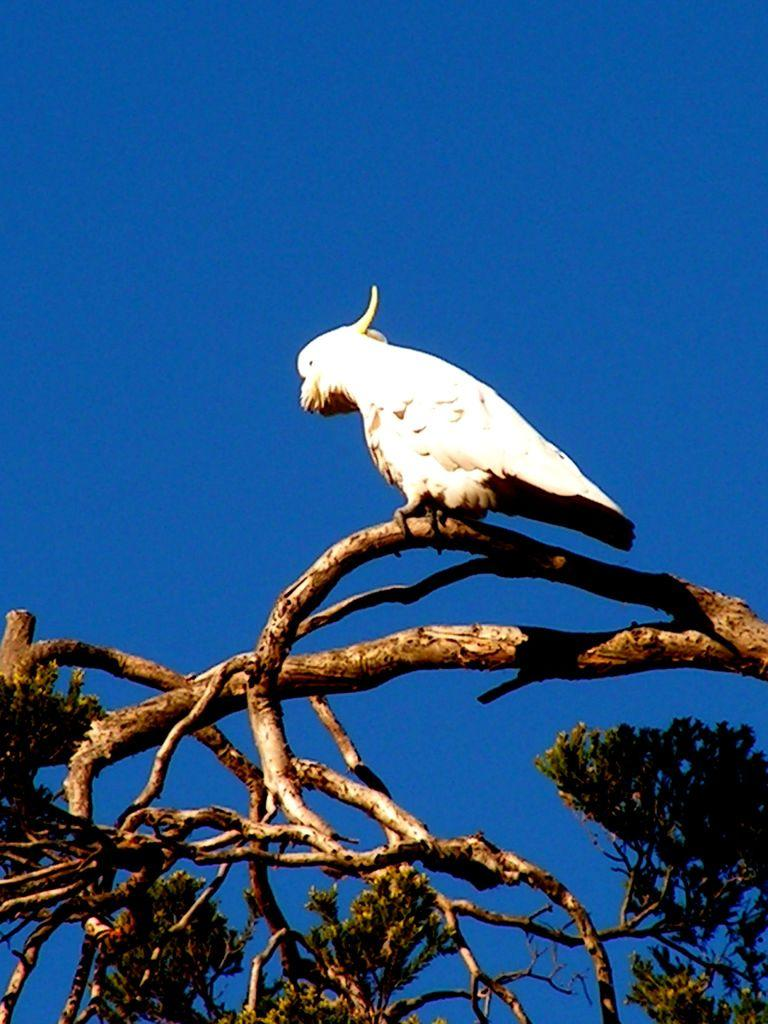What type of animal is in the image? There is a bird in the image. Where is the bird located? The bird is on a tree. What can be seen in the background of the image? There is sky visible in the background of the image. What type of punishment is the bird receiving in the image? There is no indication of punishment in the image; the bird is simply perched on a tree. 